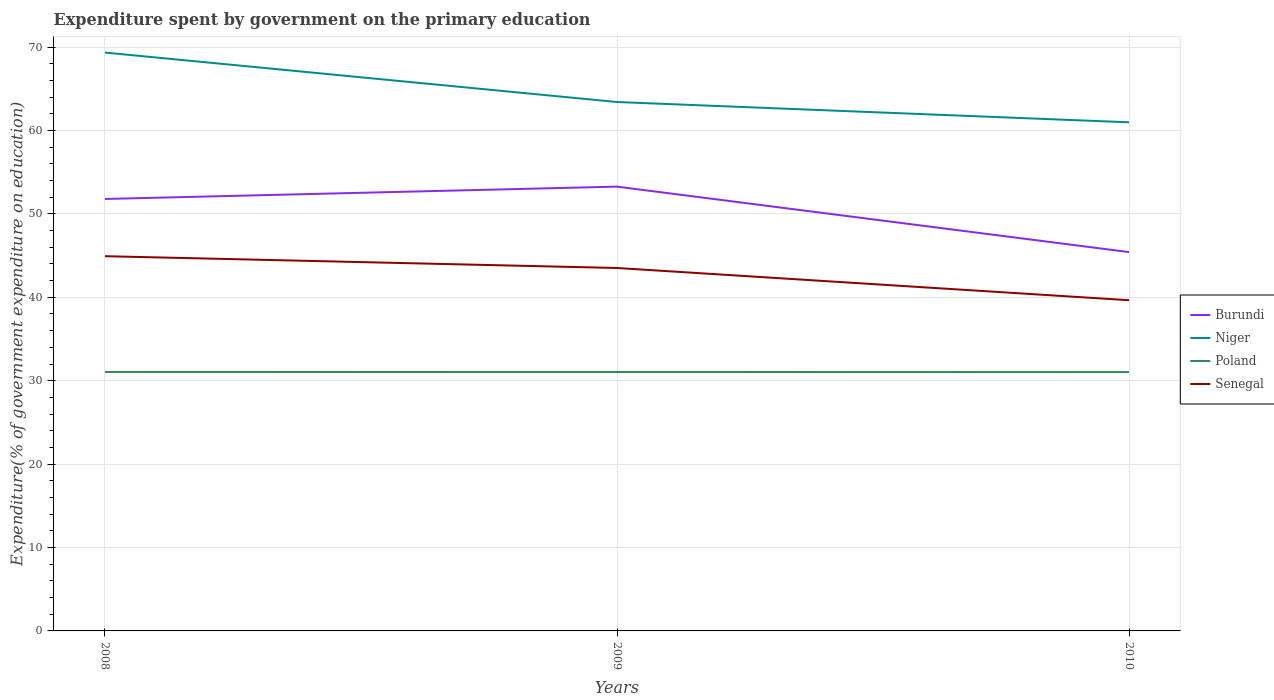Is the number of lines equal to the number of legend labels?
Provide a short and direct response. Yes. Across all years, what is the maximum expenditure spent by government on the primary education in Poland?
Keep it short and to the point. 31.03. What is the total expenditure spent by government on the primary education in Poland in the graph?
Offer a terse response. 0.01. What is the difference between the highest and the second highest expenditure spent by government on the primary education in Senegal?
Offer a terse response. 5.28. Where does the legend appear in the graph?
Provide a succinct answer. Center right. What is the title of the graph?
Your answer should be compact. Expenditure spent by government on the primary education. Does "Bahrain" appear as one of the legend labels in the graph?
Your response must be concise. No. What is the label or title of the X-axis?
Make the answer very short. Years. What is the label or title of the Y-axis?
Make the answer very short. Expenditure(% of government expenditure on education). What is the Expenditure(% of government expenditure on education) in Burundi in 2008?
Offer a terse response. 51.79. What is the Expenditure(% of government expenditure on education) of Niger in 2008?
Ensure brevity in your answer.  69.34. What is the Expenditure(% of government expenditure on education) of Poland in 2008?
Provide a short and direct response. 31.05. What is the Expenditure(% of government expenditure on education) in Senegal in 2008?
Provide a succinct answer. 44.93. What is the Expenditure(% of government expenditure on education) in Burundi in 2009?
Offer a terse response. 53.27. What is the Expenditure(% of government expenditure on education) of Niger in 2009?
Your answer should be very brief. 63.41. What is the Expenditure(% of government expenditure on education) in Poland in 2009?
Offer a very short reply. 31.04. What is the Expenditure(% of government expenditure on education) of Senegal in 2009?
Offer a very short reply. 43.51. What is the Expenditure(% of government expenditure on education) of Burundi in 2010?
Provide a short and direct response. 45.42. What is the Expenditure(% of government expenditure on education) of Niger in 2010?
Keep it short and to the point. 60.98. What is the Expenditure(% of government expenditure on education) of Poland in 2010?
Your answer should be compact. 31.03. What is the Expenditure(% of government expenditure on education) in Senegal in 2010?
Your answer should be compact. 39.65. Across all years, what is the maximum Expenditure(% of government expenditure on education) of Burundi?
Provide a succinct answer. 53.27. Across all years, what is the maximum Expenditure(% of government expenditure on education) in Niger?
Keep it short and to the point. 69.34. Across all years, what is the maximum Expenditure(% of government expenditure on education) in Poland?
Offer a terse response. 31.05. Across all years, what is the maximum Expenditure(% of government expenditure on education) of Senegal?
Provide a succinct answer. 44.93. Across all years, what is the minimum Expenditure(% of government expenditure on education) in Burundi?
Provide a short and direct response. 45.42. Across all years, what is the minimum Expenditure(% of government expenditure on education) of Niger?
Give a very brief answer. 60.98. Across all years, what is the minimum Expenditure(% of government expenditure on education) in Poland?
Offer a terse response. 31.03. Across all years, what is the minimum Expenditure(% of government expenditure on education) of Senegal?
Offer a very short reply. 39.65. What is the total Expenditure(% of government expenditure on education) of Burundi in the graph?
Provide a short and direct response. 150.47. What is the total Expenditure(% of government expenditure on education) of Niger in the graph?
Give a very brief answer. 193.73. What is the total Expenditure(% of government expenditure on education) in Poland in the graph?
Your answer should be very brief. 93.12. What is the total Expenditure(% of government expenditure on education) of Senegal in the graph?
Give a very brief answer. 128.09. What is the difference between the Expenditure(% of government expenditure on education) in Burundi in 2008 and that in 2009?
Your answer should be very brief. -1.48. What is the difference between the Expenditure(% of government expenditure on education) in Niger in 2008 and that in 2009?
Make the answer very short. 5.93. What is the difference between the Expenditure(% of government expenditure on education) of Poland in 2008 and that in 2009?
Offer a very short reply. 0. What is the difference between the Expenditure(% of government expenditure on education) in Senegal in 2008 and that in 2009?
Ensure brevity in your answer.  1.41. What is the difference between the Expenditure(% of government expenditure on education) in Burundi in 2008 and that in 2010?
Give a very brief answer. 6.37. What is the difference between the Expenditure(% of government expenditure on education) of Niger in 2008 and that in 2010?
Provide a succinct answer. 8.36. What is the difference between the Expenditure(% of government expenditure on education) in Poland in 2008 and that in 2010?
Offer a very short reply. 0.01. What is the difference between the Expenditure(% of government expenditure on education) of Senegal in 2008 and that in 2010?
Make the answer very short. 5.28. What is the difference between the Expenditure(% of government expenditure on education) of Burundi in 2009 and that in 2010?
Give a very brief answer. 7.85. What is the difference between the Expenditure(% of government expenditure on education) in Niger in 2009 and that in 2010?
Keep it short and to the point. 2.43. What is the difference between the Expenditure(% of government expenditure on education) in Poland in 2009 and that in 2010?
Your answer should be very brief. 0.01. What is the difference between the Expenditure(% of government expenditure on education) of Senegal in 2009 and that in 2010?
Keep it short and to the point. 3.87. What is the difference between the Expenditure(% of government expenditure on education) of Burundi in 2008 and the Expenditure(% of government expenditure on education) of Niger in 2009?
Your answer should be compact. -11.62. What is the difference between the Expenditure(% of government expenditure on education) of Burundi in 2008 and the Expenditure(% of government expenditure on education) of Poland in 2009?
Your answer should be very brief. 20.74. What is the difference between the Expenditure(% of government expenditure on education) in Burundi in 2008 and the Expenditure(% of government expenditure on education) in Senegal in 2009?
Keep it short and to the point. 8.27. What is the difference between the Expenditure(% of government expenditure on education) of Niger in 2008 and the Expenditure(% of government expenditure on education) of Poland in 2009?
Ensure brevity in your answer.  38.3. What is the difference between the Expenditure(% of government expenditure on education) of Niger in 2008 and the Expenditure(% of government expenditure on education) of Senegal in 2009?
Provide a short and direct response. 25.83. What is the difference between the Expenditure(% of government expenditure on education) in Poland in 2008 and the Expenditure(% of government expenditure on education) in Senegal in 2009?
Give a very brief answer. -12.47. What is the difference between the Expenditure(% of government expenditure on education) of Burundi in 2008 and the Expenditure(% of government expenditure on education) of Niger in 2010?
Ensure brevity in your answer.  -9.19. What is the difference between the Expenditure(% of government expenditure on education) in Burundi in 2008 and the Expenditure(% of government expenditure on education) in Poland in 2010?
Provide a succinct answer. 20.75. What is the difference between the Expenditure(% of government expenditure on education) of Burundi in 2008 and the Expenditure(% of government expenditure on education) of Senegal in 2010?
Make the answer very short. 12.14. What is the difference between the Expenditure(% of government expenditure on education) in Niger in 2008 and the Expenditure(% of government expenditure on education) in Poland in 2010?
Offer a very short reply. 38.31. What is the difference between the Expenditure(% of government expenditure on education) in Niger in 2008 and the Expenditure(% of government expenditure on education) in Senegal in 2010?
Ensure brevity in your answer.  29.69. What is the difference between the Expenditure(% of government expenditure on education) in Poland in 2008 and the Expenditure(% of government expenditure on education) in Senegal in 2010?
Make the answer very short. -8.6. What is the difference between the Expenditure(% of government expenditure on education) in Burundi in 2009 and the Expenditure(% of government expenditure on education) in Niger in 2010?
Offer a terse response. -7.71. What is the difference between the Expenditure(% of government expenditure on education) of Burundi in 2009 and the Expenditure(% of government expenditure on education) of Poland in 2010?
Give a very brief answer. 22.23. What is the difference between the Expenditure(% of government expenditure on education) in Burundi in 2009 and the Expenditure(% of government expenditure on education) in Senegal in 2010?
Keep it short and to the point. 13.62. What is the difference between the Expenditure(% of government expenditure on education) in Niger in 2009 and the Expenditure(% of government expenditure on education) in Poland in 2010?
Give a very brief answer. 32.38. What is the difference between the Expenditure(% of government expenditure on education) in Niger in 2009 and the Expenditure(% of government expenditure on education) in Senegal in 2010?
Give a very brief answer. 23.76. What is the difference between the Expenditure(% of government expenditure on education) in Poland in 2009 and the Expenditure(% of government expenditure on education) in Senegal in 2010?
Make the answer very short. -8.6. What is the average Expenditure(% of government expenditure on education) of Burundi per year?
Your response must be concise. 50.16. What is the average Expenditure(% of government expenditure on education) in Niger per year?
Provide a short and direct response. 64.58. What is the average Expenditure(% of government expenditure on education) in Poland per year?
Your answer should be very brief. 31.04. What is the average Expenditure(% of government expenditure on education) of Senegal per year?
Give a very brief answer. 42.7. In the year 2008, what is the difference between the Expenditure(% of government expenditure on education) of Burundi and Expenditure(% of government expenditure on education) of Niger?
Ensure brevity in your answer.  -17.55. In the year 2008, what is the difference between the Expenditure(% of government expenditure on education) of Burundi and Expenditure(% of government expenditure on education) of Poland?
Offer a terse response. 20.74. In the year 2008, what is the difference between the Expenditure(% of government expenditure on education) in Burundi and Expenditure(% of government expenditure on education) in Senegal?
Make the answer very short. 6.86. In the year 2008, what is the difference between the Expenditure(% of government expenditure on education) in Niger and Expenditure(% of government expenditure on education) in Poland?
Give a very brief answer. 38.29. In the year 2008, what is the difference between the Expenditure(% of government expenditure on education) of Niger and Expenditure(% of government expenditure on education) of Senegal?
Provide a short and direct response. 24.41. In the year 2008, what is the difference between the Expenditure(% of government expenditure on education) of Poland and Expenditure(% of government expenditure on education) of Senegal?
Give a very brief answer. -13.88. In the year 2009, what is the difference between the Expenditure(% of government expenditure on education) in Burundi and Expenditure(% of government expenditure on education) in Niger?
Keep it short and to the point. -10.14. In the year 2009, what is the difference between the Expenditure(% of government expenditure on education) of Burundi and Expenditure(% of government expenditure on education) of Poland?
Keep it short and to the point. 22.22. In the year 2009, what is the difference between the Expenditure(% of government expenditure on education) of Burundi and Expenditure(% of government expenditure on education) of Senegal?
Keep it short and to the point. 9.75. In the year 2009, what is the difference between the Expenditure(% of government expenditure on education) of Niger and Expenditure(% of government expenditure on education) of Poland?
Your answer should be very brief. 32.37. In the year 2009, what is the difference between the Expenditure(% of government expenditure on education) in Niger and Expenditure(% of government expenditure on education) in Senegal?
Offer a very short reply. 19.9. In the year 2009, what is the difference between the Expenditure(% of government expenditure on education) of Poland and Expenditure(% of government expenditure on education) of Senegal?
Make the answer very short. -12.47. In the year 2010, what is the difference between the Expenditure(% of government expenditure on education) in Burundi and Expenditure(% of government expenditure on education) in Niger?
Provide a succinct answer. -15.56. In the year 2010, what is the difference between the Expenditure(% of government expenditure on education) in Burundi and Expenditure(% of government expenditure on education) in Poland?
Your answer should be compact. 14.38. In the year 2010, what is the difference between the Expenditure(% of government expenditure on education) in Burundi and Expenditure(% of government expenditure on education) in Senegal?
Provide a short and direct response. 5.77. In the year 2010, what is the difference between the Expenditure(% of government expenditure on education) in Niger and Expenditure(% of government expenditure on education) in Poland?
Offer a very short reply. 29.94. In the year 2010, what is the difference between the Expenditure(% of government expenditure on education) in Niger and Expenditure(% of government expenditure on education) in Senegal?
Ensure brevity in your answer.  21.33. In the year 2010, what is the difference between the Expenditure(% of government expenditure on education) in Poland and Expenditure(% of government expenditure on education) in Senegal?
Make the answer very short. -8.61. What is the ratio of the Expenditure(% of government expenditure on education) in Burundi in 2008 to that in 2009?
Give a very brief answer. 0.97. What is the ratio of the Expenditure(% of government expenditure on education) of Niger in 2008 to that in 2009?
Keep it short and to the point. 1.09. What is the ratio of the Expenditure(% of government expenditure on education) of Poland in 2008 to that in 2009?
Offer a terse response. 1. What is the ratio of the Expenditure(% of government expenditure on education) in Senegal in 2008 to that in 2009?
Your answer should be compact. 1.03. What is the ratio of the Expenditure(% of government expenditure on education) of Burundi in 2008 to that in 2010?
Your response must be concise. 1.14. What is the ratio of the Expenditure(% of government expenditure on education) of Niger in 2008 to that in 2010?
Your answer should be compact. 1.14. What is the ratio of the Expenditure(% of government expenditure on education) in Senegal in 2008 to that in 2010?
Your answer should be compact. 1.13. What is the ratio of the Expenditure(% of government expenditure on education) in Burundi in 2009 to that in 2010?
Ensure brevity in your answer.  1.17. What is the ratio of the Expenditure(% of government expenditure on education) in Niger in 2009 to that in 2010?
Provide a succinct answer. 1.04. What is the ratio of the Expenditure(% of government expenditure on education) of Poland in 2009 to that in 2010?
Offer a very short reply. 1. What is the ratio of the Expenditure(% of government expenditure on education) in Senegal in 2009 to that in 2010?
Offer a terse response. 1.1. What is the difference between the highest and the second highest Expenditure(% of government expenditure on education) in Burundi?
Give a very brief answer. 1.48. What is the difference between the highest and the second highest Expenditure(% of government expenditure on education) of Niger?
Give a very brief answer. 5.93. What is the difference between the highest and the second highest Expenditure(% of government expenditure on education) in Poland?
Offer a terse response. 0. What is the difference between the highest and the second highest Expenditure(% of government expenditure on education) of Senegal?
Provide a succinct answer. 1.41. What is the difference between the highest and the lowest Expenditure(% of government expenditure on education) of Burundi?
Give a very brief answer. 7.85. What is the difference between the highest and the lowest Expenditure(% of government expenditure on education) of Niger?
Provide a short and direct response. 8.36. What is the difference between the highest and the lowest Expenditure(% of government expenditure on education) of Poland?
Your response must be concise. 0.01. What is the difference between the highest and the lowest Expenditure(% of government expenditure on education) in Senegal?
Your answer should be very brief. 5.28. 